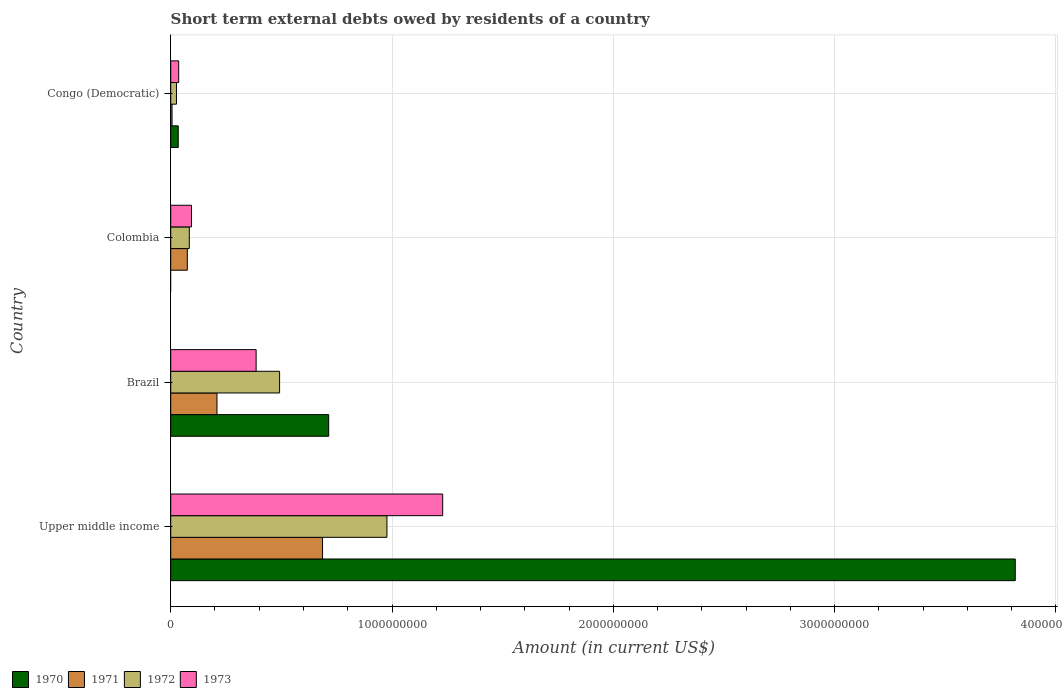How many different coloured bars are there?
Offer a terse response. 4. What is the label of the 1st group of bars from the top?
Keep it short and to the point. Congo (Democratic). What is the amount of short-term external debts owed by residents in 1972 in Brazil?
Make the answer very short. 4.92e+08. Across all countries, what is the maximum amount of short-term external debts owed by residents in 1972?
Make the answer very short. 9.77e+08. Across all countries, what is the minimum amount of short-term external debts owed by residents in 1972?
Your answer should be compact. 2.60e+07. In which country was the amount of short-term external debts owed by residents in 1973 maximum?
Provide a short and direct response. Upper middle income. What is the total amount of short-term external debts owed by residents in 1971 in the graph?
Your answer should be compact. 9.76e+08. What is the difference between the amount of short-term external debts owed by residents in 1970 in Brazil and that in Congo (Democratic)?
Make the answer very short. 6.80e+08. What is the difference between the amount of short-term external debts owed by residents in 1970 in Congo (Democratic) and the amount of short-term external debts owed by residents in 1973 in Brazil?
Your answer should be very brief. -3.52e+08. What is the average amount of short-term external debts owed by residents in 1973 per country?
Provide a succinct answer. 4.36e+08. What is the difference between the amount of short-term external debts owed by residents in 1971 and amount of short-term external debts owed by residents in 1972 in Upper middle income?
Your response must be concise. -2.91e+08. In how many countries, is the amount of short-term external debts owed by residents in 1973 greater than 2400000000 US$?
Ensure brevity in your answer.  0. What is the ratio of the amount of short-term external debts owed by residents in 1972 in Brazil to that in Upper middle income?
Provide a succinct answer. 0.5. Is the amount of short-term external debts owed by residents in 1973 in Brazil less than that in Congo (Democratic)?
Provide a succinct answer. No. What is the difference between the highest and the second highest amount of short-term external debts owed by residents in 1972?
Your answer should be compact. 4.85e+08. What is the difference between the highest and the lowest amount of short-term external debts owed by residents in 1970?
Provide a succinct answer. 3.82e+09. In how many countries, is the amount of short-term external debts owed by residents in 1973 greater than the average amount of short-term external debts owed by residents in 1973 taken over all countries?
Provide a succinct answer. 1. Is the sum of the amount of short-term external debts owed by residents in 1971 in Colombia and Upper middle income greater than the maximum amount of short-term external debts owed by residents in 1970 across all countries?
Your answer should be compact. No. Is it the case that in every country, the sum of the amount of short-term external debts owed by residents in 1972 and amount of short-term external debts owed by residents in 1971 is greater than the amount of short-term external debts owed by residents in 1973?
Your response must be concise. No. Are all the bars in the graph horizontal?
Provide a succinct answer. Yes. Are the values on the major ticks of X-axis written in scientific E-notation?
Provide a short and direct response. No. Does the graph contain any zero values?
Offer a terse response. Yes. Does the graph contain grids?
Make the answer very short. Yes. How many legend labels are there?
Give a very brief answer. 4. What is the title of the graph?
Give a very brief answer. Short term external debts owed by residents of a country. Does "2005" appear as one of the legend labels in the graph?
Ensure brevity in your answer.  No. What is the label or title of the X-axis?
Offer a terse response. Amount (in current US$). What is the label or title of the Y-axis?
Provide a short and direct response. Country. What is the Amount (in current US$) in 1970 in Upper middle income?
Your answer should be compact. 3.82e+09. What is the Amount (in current US$) in 1971 in Upper middle income?
Offer a terse response. 6.86e+08. What is the Amount (in current US$) of 1972 in Upper middle income?
Your answer should be very brief. 9.77e+08. What is the Amount (in current US$) in 1973 in Upper middle income?
Make the answer very short. 1.23e+09. What is the Amount (in current US$) of 1970 in Brazil?
Make the answer very short. 7.14e+08. What is the Amount (in current US$) of 1971 in Brazil?
Your response must be concise. 2.09e+08. What is the Amount (in current US$) of 1972 in Brazil?
Give a very brief answer. 4.92e+08. What is the Amount (in current US$) of 1973 in Brazil?
Offer a very short reply. 3.86e+08. What is the Amount (in current US$) in 1971 in Colombia?
Make the answer very short. 7.50e+07. What is the Amount (in current US$) in 1972 in Colombia?
Make the answer very short. 8.40e+07. What is the Amount (in current US$) in 1973 in Colombia?
Your answer should be compact. 9.40e+07. What is the Amount (in current US$) in 1970 in Congo (Democratic)?
Your answer should be compact. 3.40e+07. What is the Amount (in current US$) in 1971 in Congo (Democratic)?
Give a very brief answer. 6.00e+06. What is the Amount (in current US$) in 1972 in Congo (Democratic)?
Your answer should be compact. 2.60e+07. What is the Amount (in current US$) of 1973 in Congo (Democratic)?
Ensure brevity in your answer.  3.60e+07. Across all countries, what is the maximum Amount (in current US$) of 1970?
Your answer should be very brief. 3.82e+09. Across all countries, what is the maximum Amount (in current US$) of 1971?
Keep it short and to the point. 6.86e+08. Across all countries, what is the maximum Amount (in current US$) in 1972?
Your answer should be compact. 9.77e+08. Across all countries, what is the maximum Amount (in current US$) in 1973?
Keep it short and to the point. 1.23e+09. Across all countries, what is the minimum Amount (in current US$) of 1970?
Ensure brevity in your answer.  0. Across all countries, what is the minimum Amount (in current US$) in 1972?
Offer a very short reply. 2.60e+07. Across all countries, what is the minimum Amount (in current US$) of 1973?
Your answer should be very brief. 3.60e+07. What is the total Amount (in current US$) in 1970 in the graph?
Provide a short and direct response. 4.56e+09. What is the total Amount (in current US$) in 1971 in the graph?
Provide a short and direct response. 9.76e+08. What is the total Amount (in current US$) of 1972 in the graph?
Your response must be concise. 1.58e+09. What is the total Amount (in current US$) in 1973 in the graph?
Your answer should be very brief. 1.75e+09. What is the difference between the Amount (in current US$) of 1970 in Upper middle income and that in Brazil?
Your answer should be compact. 3.10e+09. What is the difference between the Amount (in current US$) in 1971 in Upper middle income and that in Brazil?
Give a very brief answer. 4.77e+08. What is the difference between the Amount (in current US$) in 1972 in Upper middle income and that in Brazil?
Give a very brief answer. 4.85e+08. What is the difference between the Amount (in current US$) of 1973 in Upper middle income and that in Brazil?
Your response must be concise. 8.43e+08. What is the difference between the Amount (in current US$) of 1971 in Upper middle income and that in Colombia?
Ensure brevity in your answer.  6.11e+08. What is the difference between the Amount (in current US$) of 1972 in Upper middle income and that in Colombia?
Keep it short and to the point. 8.93e+08. What is the difference between the Amount (in current US$) in 1973 in Upper middle income and that in Colombia?
Make the answer very short. 1.14e+09. What is the difference between the Amount (in current US$) of 1970 in Upper middle income and that in Congo (Democratic)?
Ensure brevity in your answer.  3.78e+09. What is the difference between the Amount (in current US$) in 1971 in Upper middle income and that in Congo (Democratic)?
Make the answer very short. 6.80e+08. What is the difference between the Amount (in current US$) of 1972 in Upper middle income and that in Congo (Democratic)?
Your answer should be very brief. 9.51e+08. What is the difference between the Amount (in current US$) in 1973 in Upper middle income and that in Congo (Democratic)?
Provide a succinct answer. 1.19e+09. What is the difference between the Amount (in current US$) of 1971 in Brazil and that in Colombia?
Ensure brevity in your answer.  1.34e+08. What is the difference between the Amount (in current US$) of 1972 in Brazil and that in Colombia?
Make the answer very short. 4.08e+08. What is the difference between the Amount (in current US$) in 1973 in Brazil and that in Colombia?
Keep it short and to the point. 2.92e+08. What is the difference between the Amount (in current US$) of 1970 in Brazil and that in Congo (Democratic)?
Your response must be concise. 6.80e+08. What is the difference between the Amount (in current US$) in 1971 in Brazil and that in Congo (Democratic)?
Keep it short and to the point. 2.03e+08. What is the difference between the Amount (in current US$) in 1972 in Brazil and that in Congo (Democratic)?
Give a very brief answer. 4.66e+08. What is the difference between the Amount (in current US$) of 1973 in Brazil and that in Congo (Democratic)?
Your response must be concise. 3.50e+08. What is the difference between the Amount (in current US$) in 1971 in Colombia and that in Congo (Democratic)?
Ensure brevity in your answer.  6.90e+07. What is the difference between the Amount (in current US$) of 1972 in Colombia and that in Congo (Democratic)?
Your answer should be very brief. 5.80e+07. What is the difference between the Amount (in current US$) in 1973 in Colombia and that in Congo (Democratic)?
Provide a succinct answer. 5.80e+07. What is the difference between the Amount (in current US$) of 1970 in Upper middle income and the Amount (in current US$) of 1971 in Brazil?
Provide a short and direct response. 3.61e+09. What is the difference between the Amount (in current US$) in 1970 in Upper middle income and the Amount (in current US$) in 1972 in Brazil?
Your answer should be compact. 3.32e+09. What is the difference between the Amount (in current US$) in 1970 in Upper middle income and the Amount (in current US$) in 1973 in Brazil?
Make the answer very short. 3.43e+09. What is the difference between the Amount (in current US$) of 1971 in Upper middle income and the Amount (in current US$) of 1972 in Brazil?
Ensure brevity in your answer.  1.94e+08. What is the difference between the Amount (in current US$) in 1971 in Upper middle income and the Amount (in current US$) in 1973 in Brazil?
Give a very brief answer. 3.00e+08. What is the difference between the Amount (in current US$) in 1972 in Upper middle income and the Amount (in current US$) in 1973 in Brazil?
Provide a short and direct response. 5.91e+08. What is the difference between the Amount (in current US$) in 1970 in Upper middle income and the Amount (in current US$) in 1971 in Colombia?
Offer a very short reply. 3.74e+09. What is the difference between the Amount (in current US$) of 1970 in Upper middle income and the Amount (in current US$) of 1972 in Colombia?
Ensure brevity in your answer.  3.73e+09. What is the difference between the Amount (in current US$) of 1970 in Upper middle income and the Amount (in current US$) of 1973 in Colombia?
Your response must be concise. 3.72e+09. What is the difference between the Amount (in current US$) in 1971 in Upper middle income and the Amount (in current US$) in 1972 in Colombia?
Offer a very short reply. 6.02e+08. What is the difference between the Amount (in current US$) of 1971 in Upper middle income and the Amount (in current US$) of 1973 in Colombia?
Provide a short and direct response. 5.92e+08. What is the difference between the Amount (in current US$) in 1972 in Upper middle income and the Amount (in current US$) in 1973 in Colombia?
Provide a succinct answer. 8.83e+08. What is the difference between the Amount (in current US$) in 1970 in Upper middle income and the Amount (in current US$) in 1971 in Congo (Democratic)?
Provide a short and direct response. 3.81e+09. What is the difference between the Amount (in current US$) of 1970 in Upper middle income and the Amount (in current US$) of 1972 in Congo (Democratic)?
Keep it short and to the point. 3.79e+09. What is the difference between the Amount (in current US$) of 1970 in Upper middle income and the Amount (in current US$) of 1973 in Congo (Democratic)?
Offer a very short reply. 3.78e+09. What is the difference between the Amount (in current US$) in 1971 in Upper middle income and the Amount (in current US$) in 1972 in Congo (Democratic)?
Give a very brief answer. 6.60e+08. What is the difference between the Amount (in current US$) of 1971 in Upper middle income and the Amount (in current US$) of 1973 in Congo (Democratic)?
Keep it short and to the point. 6.50e+08. What is the difference between the Amount (in current US$) in 1972 in Upper middle income and the Amount (in current US$) in 1973 in Congo (Democratic)?
Offer a terse response. 9.41e+08. What is the difference between the Amount (in current US$) in 1970 in Brazil and the Amount (in current US$) in 1971 in Colombia?
Provide a succinct answer. 6.39e+08. What is the difference between the Amount (in current US$) of 1970 in Brazil and the Amount (in current US$) of 1972 in Colombia?
Your answer should be very brief. 6.30e+08. What is the difference between the Amount (in current US$) of 1970 in Brazil and the Amount (in current US$) of 1973 in Colombia?
Your response must be concise. 6.20e+08. What is the difference between the Amount (in current US$) in 1971 in Brazil and the Amount (in current US$) in 1972 in Colombia?
Ensure brevity in your answer.  1.25e+08. What is the difference between the Amount (in current US$) in 1971 in Brazil and the Amount (in current US$) in 1973 in Colombia?
Keep it short and to the point. 1.15e+08. What is the difference between the Amount (in current US$) of 1972 in Brazil and the Amount (in current US$) of 1973 in Colombia?
Provide a short and direct response. 3.98e+08. What is the difference between the Amount (in current US$) in 1970 in Brazil and the Amount (in current US$) in 1971 in Congo (Democratic)?
Offer a very short reply. 7.08e+08. What is the difference between the Amount (in current US$) of 1970 in Brazil and the Amount (in current US$) of 1972 in Congo (Democratic)?
Ensure brevity in your answer.  6.88e+08. What is the difference between the Amount (in current US$) in 1970 in Brazil and the Amount (in current US$) in 1973 in Congo (Democratic)?
Your answer should be very brief. 6.78e+08. What is the difference between the Amount (in current US$) in 1971 in Brazil and the Amount (in current US$) in 1972 in Congo (Democratic)?
Provide a short and direct response. 1.83e+08. What is the difference between the Amount (in current US$) of 1971 in Brazil and the Amount (in current US$) of 1973 in Congo (Democratic)?
Make the answer very short. 1.73e+08. What is the difference between the Amount (in current US$) in 1972 in Brazil and the Amount (in current US$) in 1973 in Congo (Democratic)?
Offer a very short reply. 4.56e+08. What is the difference between the Amount (in current US$) in 1971 in Colombia and the Amount (in current US$) in 1972 in Congo (Democratic)?
Provide a short and direct response. 4.90e+07. What is the difference between the Amount (in current US$) of 1971 in Colombia and the Amount (in current US$) of 1973 in Congo (Democratic)?
Keep it short and to the point. 3.90e+07. What is the difference between the Amount (in current US$) in 1972 in Colombia and the Amount (in current US$) in 1973 in Congo (Democratic)?
Offer a terse response. 4.80e+07. What is the average Amount (in current US$) in 1970 per country?
Give a very brief answer. 1.14e+09. What is the average Amount (in current US$) in 1971 per country?
Make the answer very short. 2.44e+08. What is the average Amount (in current US$) in 1972 per country?
Ensure brevity in your answer.  3.95e+08. What is the average Amount (in current US$) of 1973 per country?
Provide a short and direct response. 4.36e+08. What is the difference between the Amount (in current US$) of 1970 and Amount (in current US$) of 1971 in Upper middle income?
Make the answer very short. 3.13e+09. What is the difference between the Amount (in current US$) in 1970 and Amount (in current US$) in 1972 in Upper middle income?
Your response must be concise. 2.84e+09. What is the difference between the Amount (in current US$) in 1970 and Amount (in current US$) in 1973 in Upper middle income?
Give a very brief answer. 2.59e+09. What is the difference between the Amount (in current US$) of 1971 and Amount (in current US$) of 1972 in Upper middle income?
Keep it short and to the point. -2.91e+08. What is the difference between the Amount (in current US$) of 1971 and Amount (in current US$) of 1973 in Upper middle income?
Your answer should be very brief. -5.43e+08. What is the difference between the Amount (in current US$) of 1972 and Amount (in current US$) of 1973 in Upper middle income?
Provide a short and direct response. -2.52e+08. What is the difference between the Amount (in current US$) in 1970 and Amount (in current US$) in 1971 in Brazil?
Offer a terse response. 5.05e+08. What is the difference between the Amount (in current US$) in 1970 and Amount (in current US$) in 1972 in Brazil?
Give a very brief answer. 2.22e+08. What is the difference between the Amount (in current US$) of 1970 and Amount (in current US$) of 1973 in Brazil?
Make the answer very short. 3.28e+08. What is the difference between the Amount (in current US$) of 1971 and Amount (in current US$) of 1972 in Brazil?
Ensure brevity in your answer.  -2.83e+08. What is the difference between the Amount (in current US$) of 1971 and Amount (in current US$) of 1973 in Brazil?
Keep it short and to the point. -1.77e+08. What is the difference between the Amount (in current US$) of 1972 and Amount (in current US$) of 1973 in Brazil?
Offer a very short reply. 1.06e+08. What is the difference between the Amount (in current US$) in 1971 and Amount (in current US$) in 1972 in Colombia?
Provide a short and direct response. -9.00e+06. What is the difference between the Amount (in current US$) of 1971 and Amount (in current US$) of 1973 in Colombia?
Ensure brevity in your answer.  -1.90e+07. What is the difference between the Amount (in current US$) in 1972 and Amount (in current US$) in 1973 in Colombia?
Offer a terse response. -1.00e+07. What is the difference between the Amount (in current US$) in 1970 and Amount (in current US$) in 1971 in Congo (Democratic)?
Provide a short and direct response. 2.80e+07. What is the difference between the Amount (in current US$) in 1970 and Amount (in current US$) in 1972 in Congo (Democratic)?
Keep it short and to the point. 8.00e+06. What is the difference between the Amount (in current US$) of 1970 and Amount (in current US$) of 1973 in Congo (Democratic)?
Provide a short and direct response. -2.00e+06. What is the difference between the Amount (in current US$) in 1971 and Amount (in current US$) in 1972 in Congo (Democratic)?
Offer a terse response. -2.00e+07. What is the difference between the Amount (in current US$) of 1971 and Amount (in current US$) of 1973 in Congo (Democratic)?
Offer a very short reply. -3.00e+07. What is the difference between the Amount (in current US$) of 1972 and Amount (in current US$) of 1973 in Congo (Democratic)?
Provide a short and direct response. -1.00e+07. What is the ratio of the Amount (in current US$) of 1970 in Upper middle income to that in Brazil?
Your answer should be compact. 5.35. What is the ratio of the Amount (in current US$) of 1971 in Upper middle income to that in Brazil?
Give a very brief answer. 3.28. What is the ratio of the Amount (in current US$) of 1972 in Upper middle income to that in Brazil?
Ensure brevity in your answer.  1.99. What is the ratio of the Amount (in current US$) of 1973 in Upper middle income to that in Brazil?
Offer a very short reply. 3.18. What is the ratio of the Amount (in current US$) of 1971 in Upper middle income to that in Colombia?
Your response must be concise. 9.15. What is the ratio of the Amount (in current US$) of 1972 in Upper middle income to that in Colombia?
Your response must be concise. 11.63. What is the ratio of the Amount (in current US$) of 1973 in Upper middle income to that in Colombia?
Make the answer very short. 13.08. What is the ratio of the Amount (in current US$) of 1970 in Upper middle income to that in Congo (Democratic)?
Keep it short and to the point. 112.25. What is the ratio of the Amount (in current US$) of 1971 in Upper middle income to that in Congo (Democratic)?
Ensure brevity in your answer.  114.35. What is the ratio of the Amount (in current US$) of 1972 in Upper middle income to that in Congo (Democratic)?
Provide a succinct answer. 37.58. What is the ratio of the Amount (in current US$) in 1973 in Upper middle income to that in Congo (Democratic)?
Make the answer very short. 34.14. What is the ratio of the Amount (in current US$) in 1971 in Brazil to that in Colombia?
Give a very brief answer. 2.79. What is the ratio of the Amount (in current US$) in 1972 in Brazil to that in Colombia?
Provide a short and direct response. 5.86. What is the ratio of the Amount (in current US$) in 1973 in Brazil to that in Colombia?
Make the answer very short. 4.11. What is the ratio of the Amount (in current US$) of 1970 in Brazil to that in Congo (Democratic)?
Provide a short and direct response. 21. What is the ratio of the Amount (in current US$) of 1971 in Brazil to that in Congo (Democratic)?
Offer a very short reply. 34.83. What is the ratio of the Amount (in current US$) in 1972 in Brazil to that in Congo (Democratic)?
Offer a terse response. 18.92. What is the ratio of the Amount (in current US$) in 1973 in Brazil to that in Congo (Democratic)?
Keep it short and to the point. 10.72. What is the ratio of the Amount (in current US$) in 1971 in Colombia to that in Congo (Democratic)?
Your response must be concise. 12.5. What is the ratio of the Amount (in current US$) of 1972 in Colombia to that in Congo (Democratic)?
Keep it short and to the point. 3.23. What is the ratio of the Amount (in current US$) of 1973 in Colombia to that in Congo (Democratic)?
Keep it short and to the point. 2.61. What is the difference between the highest and the second highest Amount (in current US$) in 1970?
Provide a succinct answer. 3.10e+09. What is the difference between the highest and the second highest Amount (in current US$) in 1971?
Your response must be concise. 4.77e+08. What is the difference between the highest and the second highest Amount (in current US$) of 1972?
Keep it short and to the point. 4.85e+08. What is the difference between the highest and the second highest Amount (in current US$) in 1973?
Offer a very short reply. 8.43e+08. What is the difference between the highest and the lowest Amount (in current US$) of 1970?
Your response must be concise. 3.82e+09. What is the difference between the highest and the lowest Amount (in current US$) in 1971?
Offer a terse response. 6.80e+08. What is the difference between the highest and the lowest Amount (in current US$) of 1972?
Provide a succinct answer. 9.51e+08. What is the difference between the highest and the lowest Amount (in current US$) in 1973?
Your answer should be very brief. 1.19e+09. 